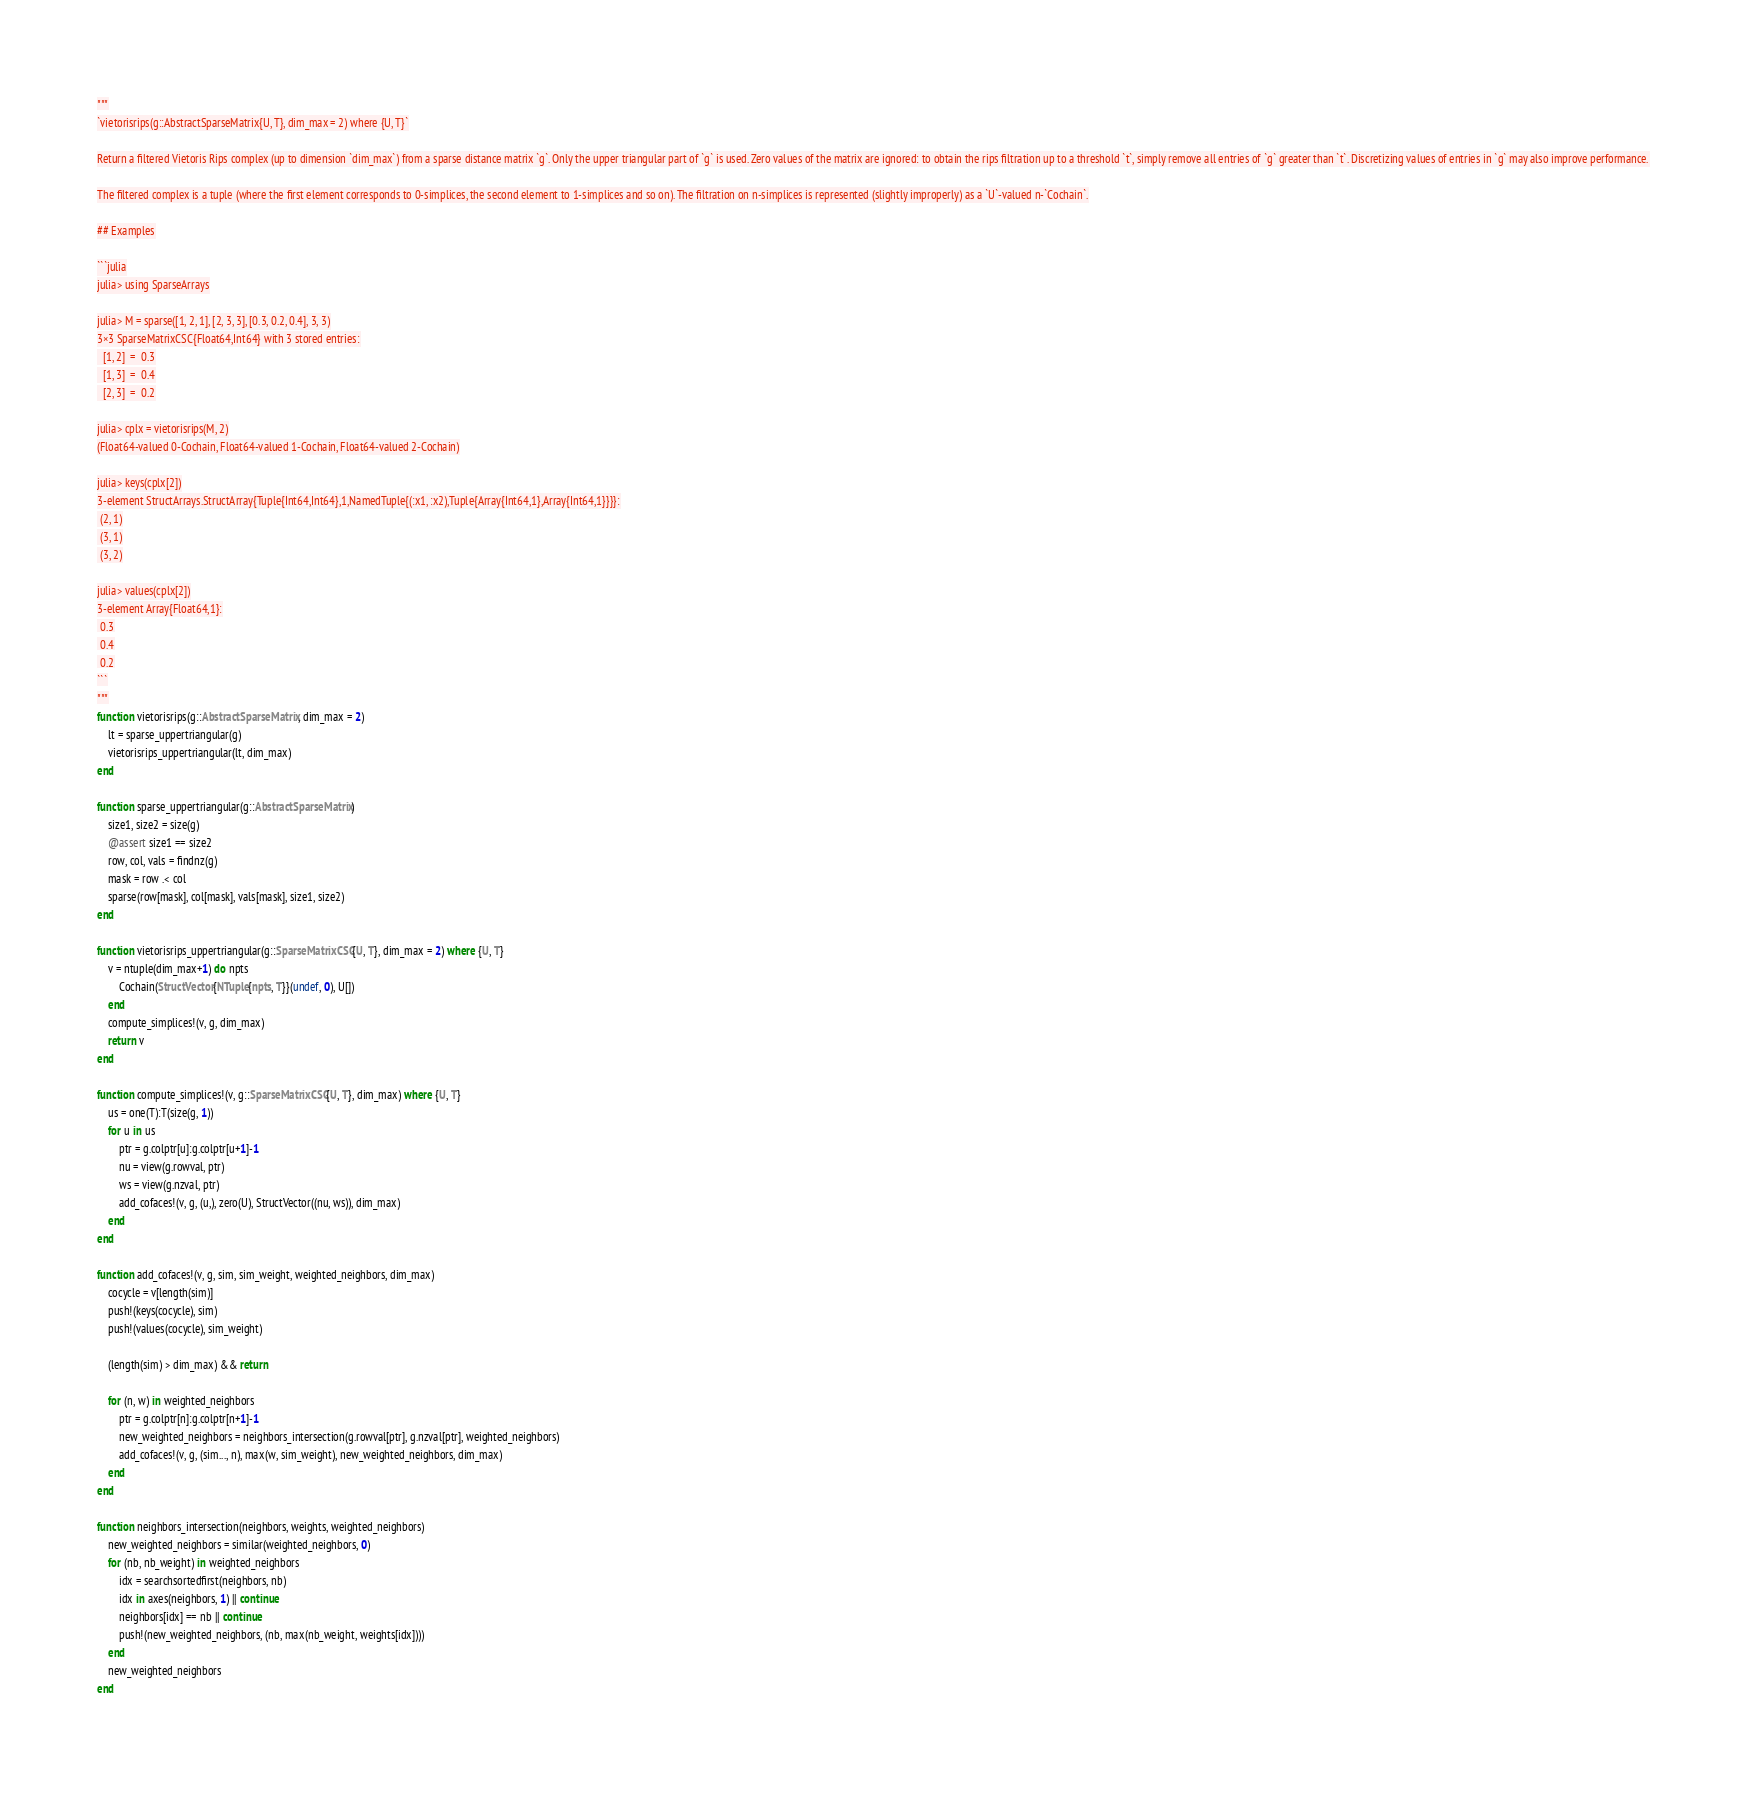Convert code to text. <code><loc_0><loc_0><loc_500><loc_500><_Julia_>"""
`vietorisrips(g::AbstractSparseMatrix{U, T}, dim_max = 2) where {U, T}`

Return a filtered Vietoris Rips complex (up to dimension `dim_max`) from a sparse distance matrix `g`. Only the upper triangular part of `g` is used. Zero values of the matrix are ignored: to obtain the rips filtration up to a threshold `t`, simply remove all entries of `g` greater than `t`. Discretizing values of entries in `g` may also improve performance.

The filtered complex is a tuple (where the first element corresponds to 0-simplices, the second element to 1-simplices and so on). The filtration on n-simplices is represented (slightly improperly) as a `U`-valued n-`Cochain`.

## Examples

```julia
julia> using SparseArrays

julia> M = sparse([1, 2, 1], [2, 3, 3], [0.3, 0.2, 0.4], 3, 3)
3×3 SparseMatrixCSC{Float64,Int64} with 3 stored entries:
  [1, 2]  =  0.3
  [1, 3]  =  0.4
  [2, 3]  =  0.2

julia> cplx = vietorisrips(M, 2)
(Float64-valued 0-Cochain, Float64-valued 1-Cochain, Float64-valued 2-Cochain)

julia> keys(cplx[2])
3-element StructArrays.StructArray{Tuple{Int64,Int64},1,NamedTuple{(:x1, :x2),Tuple{Array{Int64,1},Array{Int64,1}}}}:
 (2, 1)
 (3, 1)
 (3, 2)

julia> values(cplx[2])
3-element Array{Float64,1}:
 0.3
 0.4
 0.2
```
"""
function vietorisrips(g::AbstractSparseMatrix, dim_max = 2)
    lt = sparse_uppertriangular(g)
    vietorisrips_uppertriangular(lt, dim_max)
end

function sparse_uppertriangular(g::AbstractSparseMatrix)
    size1, size2 = size(g)
    @assert size1 == size2
    row, col, vals = findnz(g)
    mask = row .< col
    sparse(row[mask], col[mask], vals[mask], size1, size2)
end 

function vietorisrips_uppertriangular(g::SparseMatrixCSC{U, T}, dim_max = 2) where {U, T}
    v = ntuple(dim_max+1) do npts
        Cochain(StructVector{NTuple{npts, T}}(undef, 0), U[])
    end
    compute_simplices!(v, g, dim_max)
    return v
end

function compute_simplices!(v, g::SparseMatrixCSC{U, T}, dim_max) where {U, T}
    us = one(T):T(size(g, 1))
    for u in us
        ptr = g.colptr[u]:g.colptr[u+1]-1
        nu = view(g.rowval, ptr)
        ws = view(g.nzval, ptr)
        add_cofaces!(v, g, (u,), zero(U), StructVector((nu, ws)), dim_max)
    end
end

function add_cofaces!(v, g, sim, sim_weight, weighted_neighbors, dim_max)
    cocycle = v[length(sim)]
    push!(keys(cocycle), sim)
    push!(values(cocycle), sim_weight)

    (length(sim) > dim_max) && return

    for (n, w) in weighted_neighbors
        ptr = g.colptr[n]:g.colptr[n+1]-1
        new_weighted_neighbors = neighbors_intersection(g.rowval[ptr], g.nzval[ptr], weighted_neighbors)
        add_cofaces!(v, g, (sim..., n), max(w, sim_weight), new_weighted_neighbors, dim_max)
    end
end

function neighbors_intersection(neighbors, weights, weighted_neighbors)
    new_weighted_neighbors = similar(weighted_neighbors, 0)
    for (nb, nb_weight) in weighted_neighbors
        idx = searchsortedfirst(neighbors, nb)
        idx in axes(neighbors, 1) || continue
        neighbors[idx] == nb || continue
        push!(new_weighted_neighbors, (nb, max(nb_weight, weights[idx])))
    end
    new_weighted_neighbors
end
</code> 